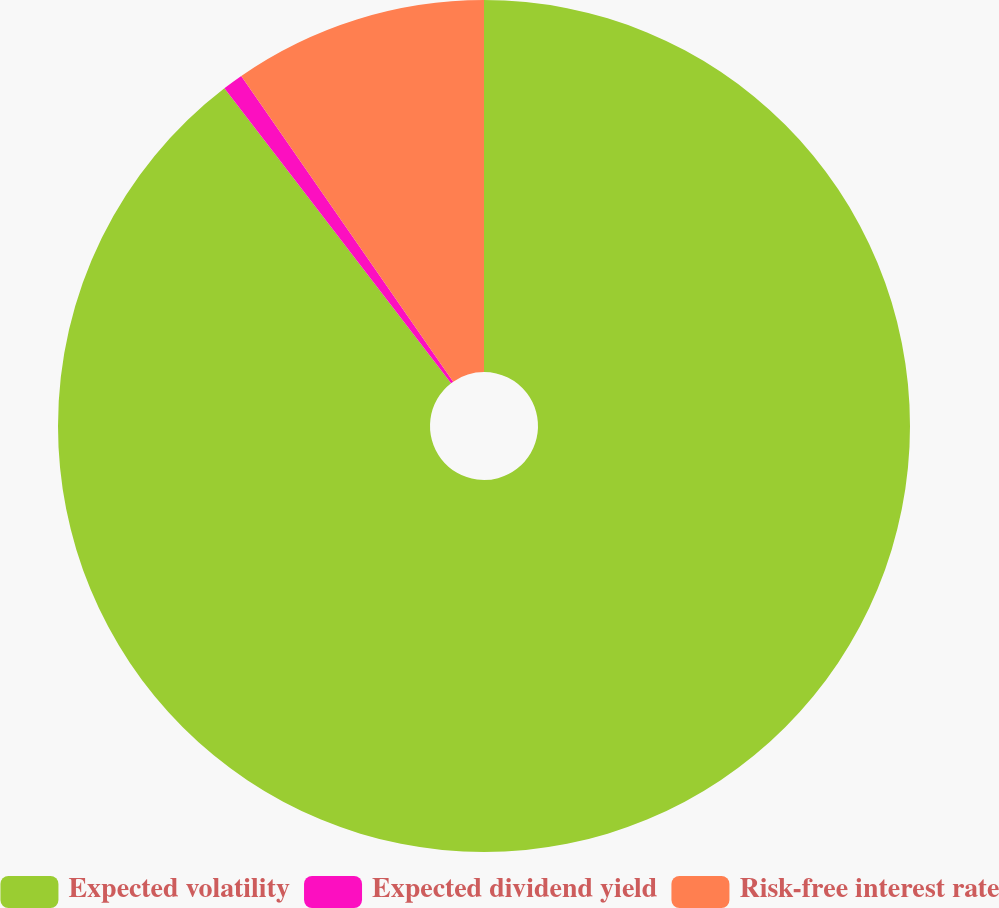Convert chart to OTSL. <chart><loc_0><loc_0><loc_500><loc_500><pie_chart><fcel>Expected volatility<fcel>Expected dividend yield<fcel>Risk-free interest rate<nl><fcel>89.57%<fcel>0.78%<fcel>9.65%<nl></chart> 